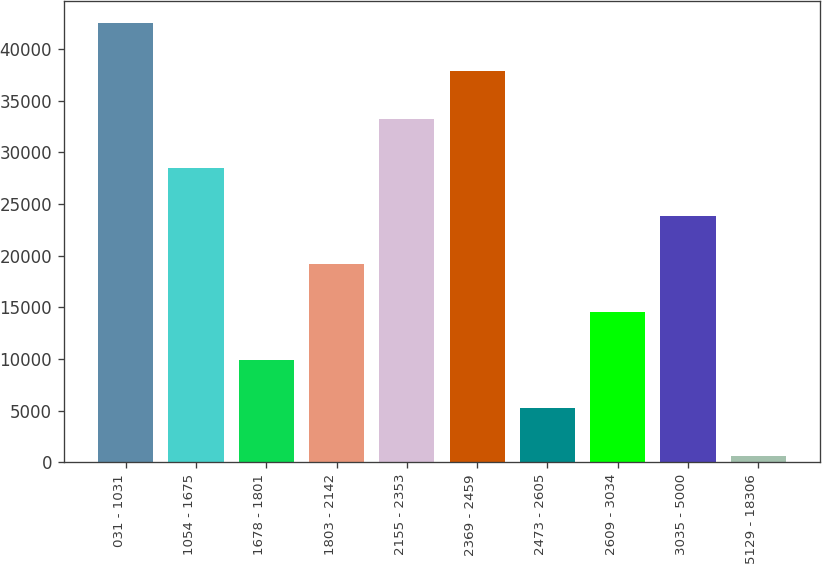Convert chart. <chart><loc_0><loc_0><loc_500><loc_500><bar_chart><fcel>031 - 1031<fcel>1054 - 1675<fcel>1678 - 1801<fcel>1803 - 2142<fcel>2155 - 2353<fcel>2369 - 2459<fcel>2473 - 2605<fcel>2609 - 3034<fcel>3035 - 5000<fcel>5129 - 18306<nl><fcel>42516.3<fcel>28537.2<fcel>9898.4<fcel>19217.8<fcel>33196.9<fcel>37856.6<fcel>5238.7<fcel>14558.1<fcel>23877.5<fcel>579<nl></chart> 